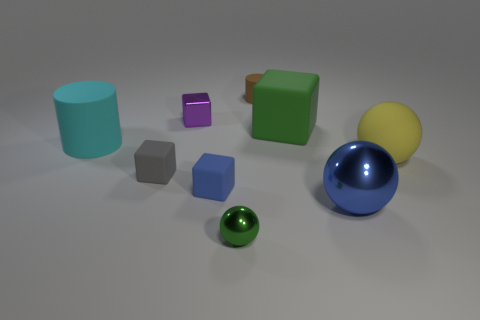Subtract all cubes. How many objects are left? 5 Subtract all tiny purple shiny cubes. Subtract all large green things. How many objects are left? 7 Add 7 cyan matte cylinders. How many cyan matte cylinders are left? 8 Add 5 small spheres. How many small spheres exist? 6 Subtract 0 red balls. How many objects are left? 9 